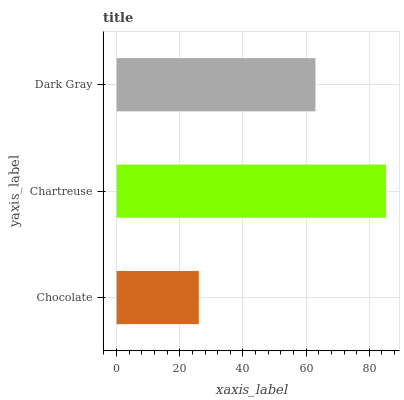Is Chocolate the minimum?
Answer yes or no. Yes. Is Chartreuse the maximum?
Answer yes or no. Yes. Is Dark Gray the minimum?
Answer yes or no. No. Is Dark Gray the maximum?
Answer yes or no. No. Is Chartreuse greater than Dark Gray?
Answer yes or no. Yes. Is Dark Gray less than Chartreuse?
Answer yes or no. Yes. Is Dark Gray greater than Chartreuse?
Answer yes or no. No. Is Chartreuse less than Dark Gray?
Answer yes or no. No. Is Dark Gray the high median?
Answer yes or no. Yes. Is Dark Gray the low median?
Answer yes or no. Yes. Is Chartreuse the high median?
Answer yes or no. No. Is Chartreuse the low median?
Answer yes or no. No. 